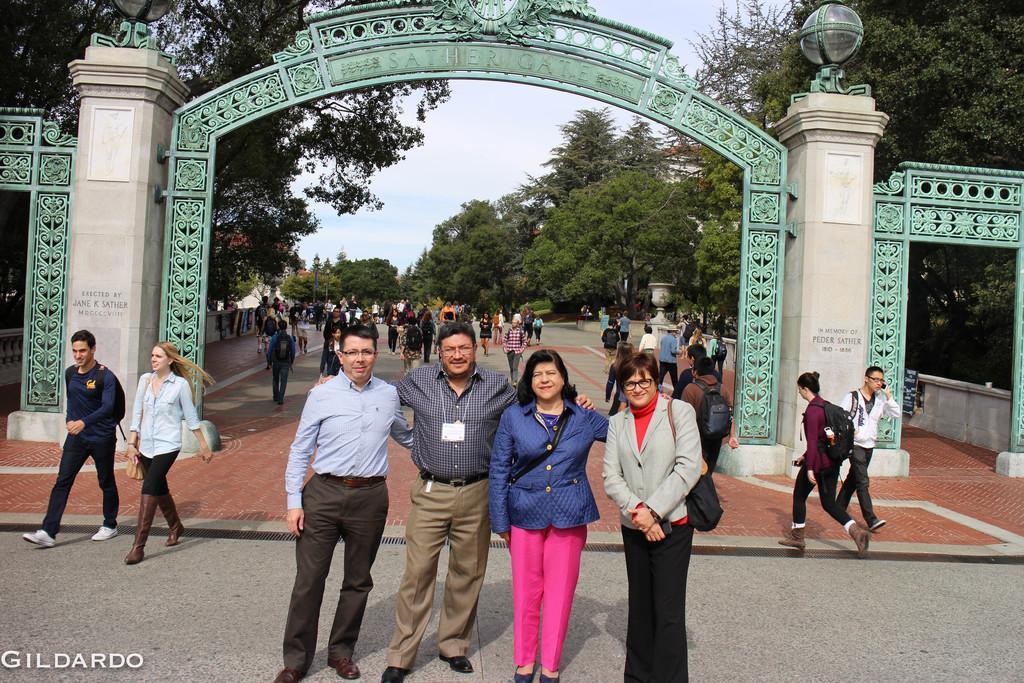Could you give a brief overview of what you see in this image? In the foreground I can see two men and two women standing, smiling and giving pose for the picture. At the back of the these people I can see an arch. In the background many people are walking on the road. On both sides of the road I can see the trees. At the top of the image I can see the sky. 